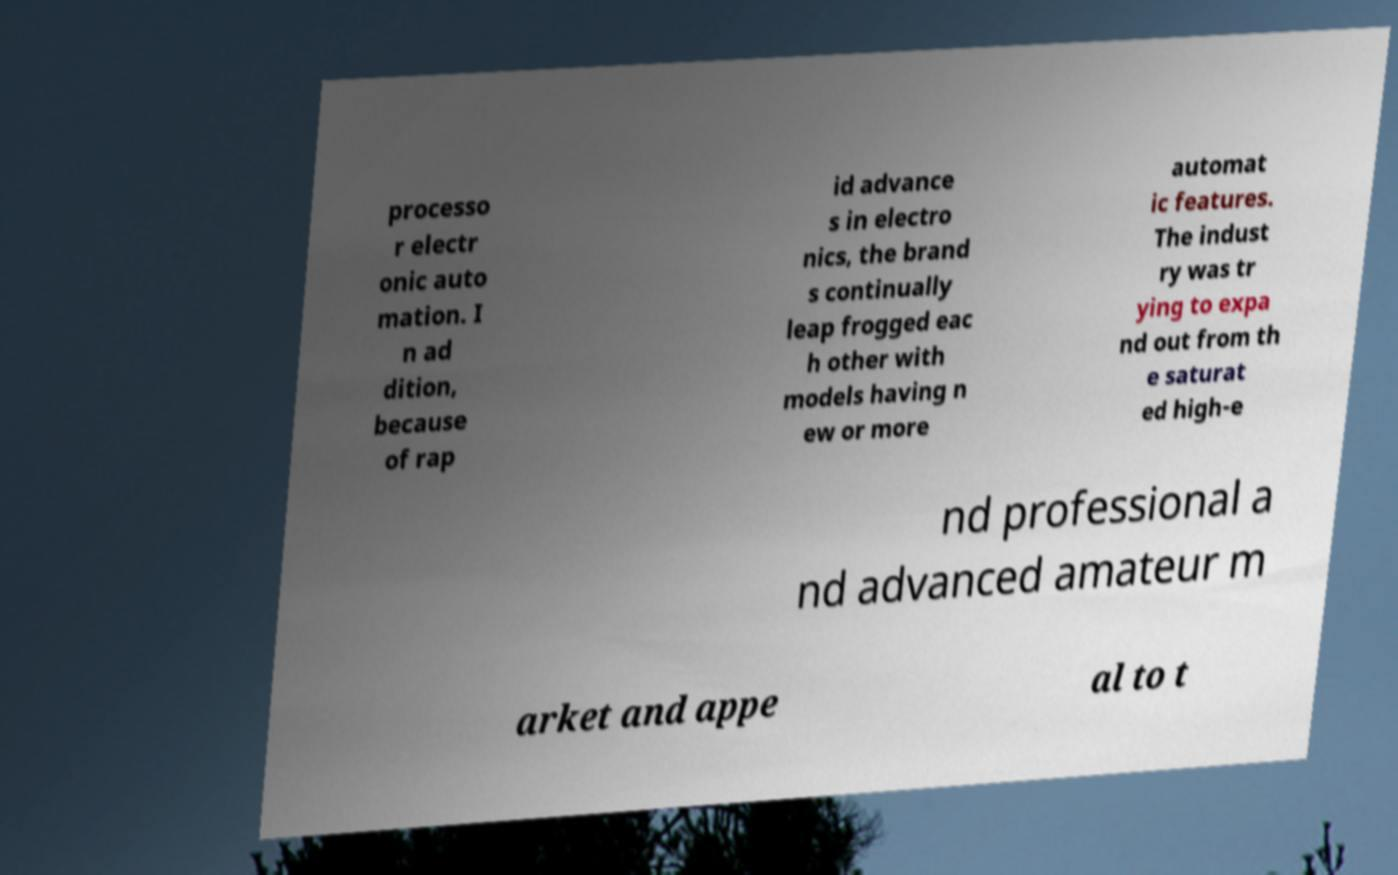What messages or text are displayed in this image? I need them in a readable, typed format. processo r electr onic auto mation. I n ad dition, because of rap id advance s in electro nics, the brand s continually leap frogged eac h other with models having n ew or more automat ic features. The indust ry was tr ying to expa nd out from th e saturat ed high-e nd professional a nd advanced amateur m arket and appe al to t 